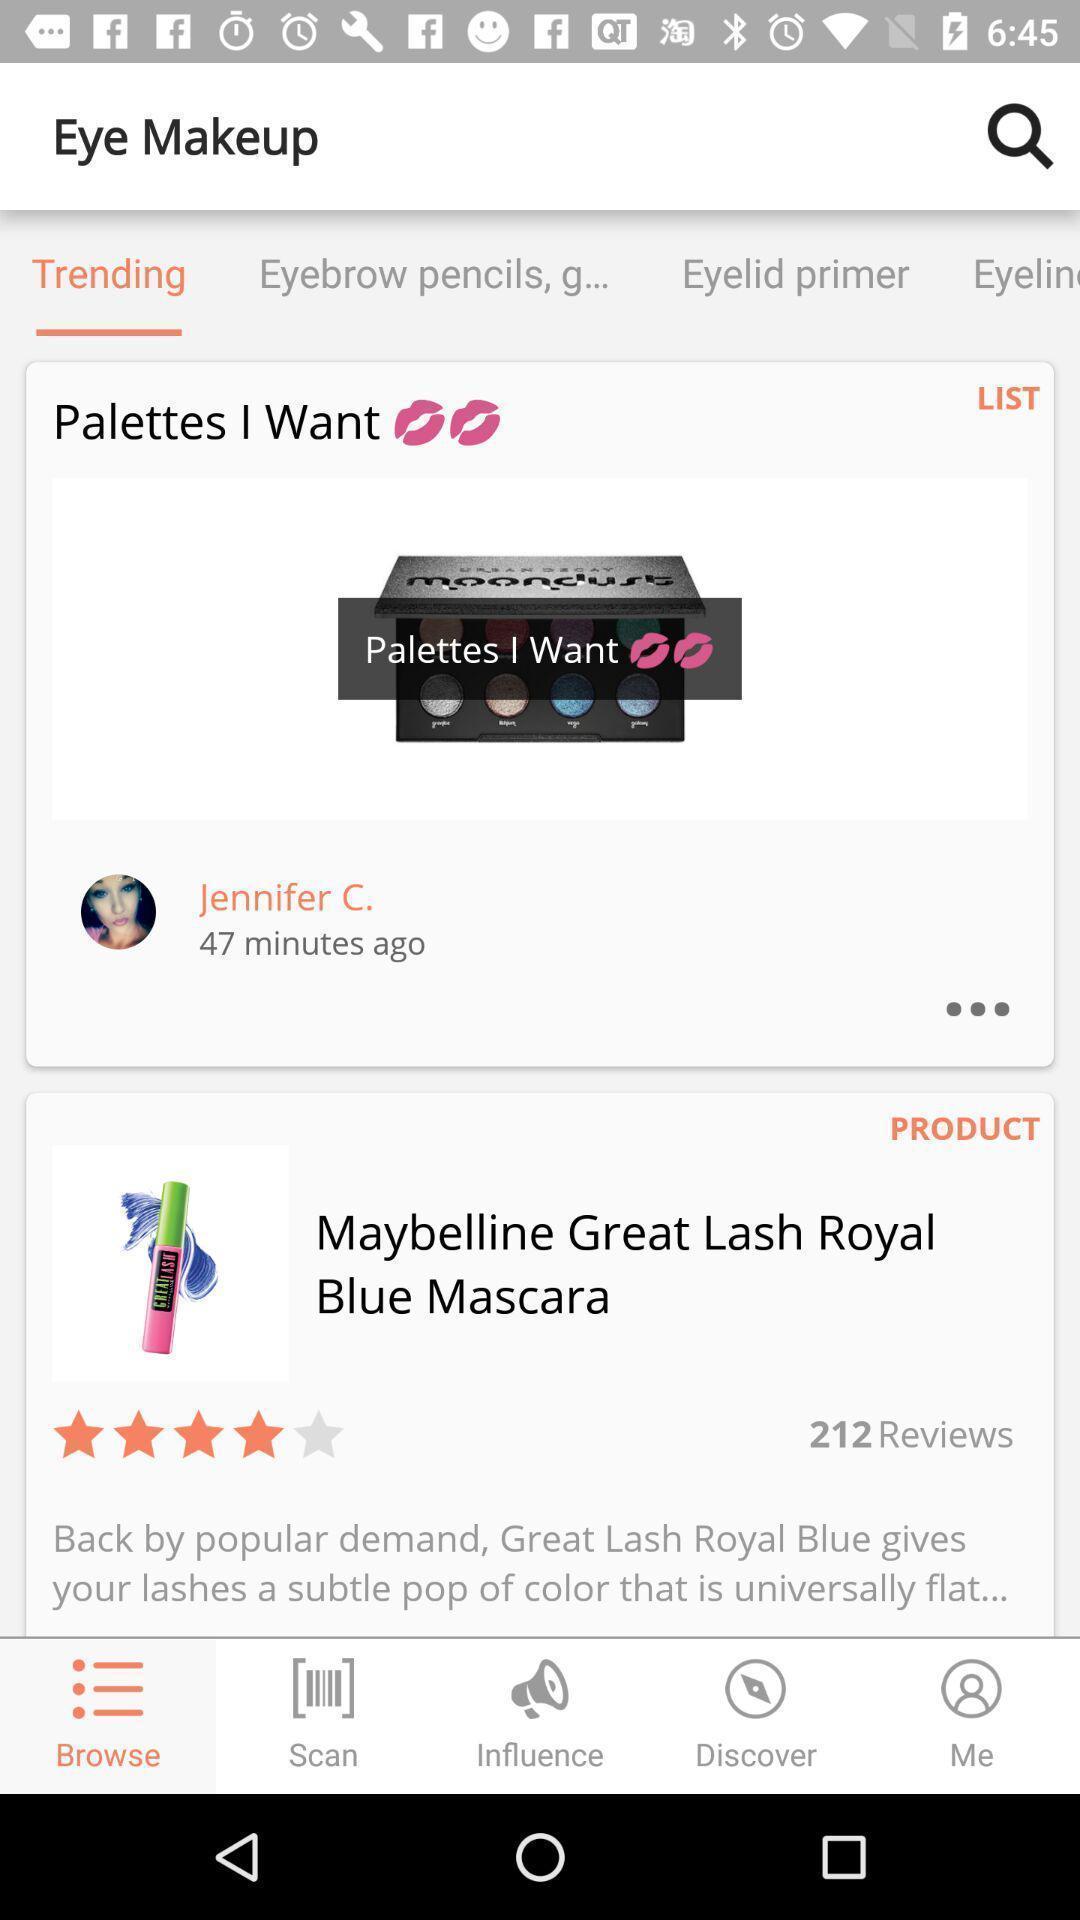Provide a textual representation of this image. Page displaying the eye makeup products. 